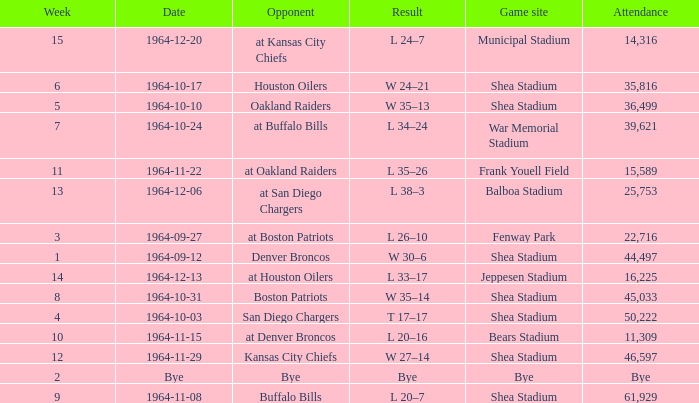Where did the Jet's play with an attendance of 11,309? Bears Stadium. 